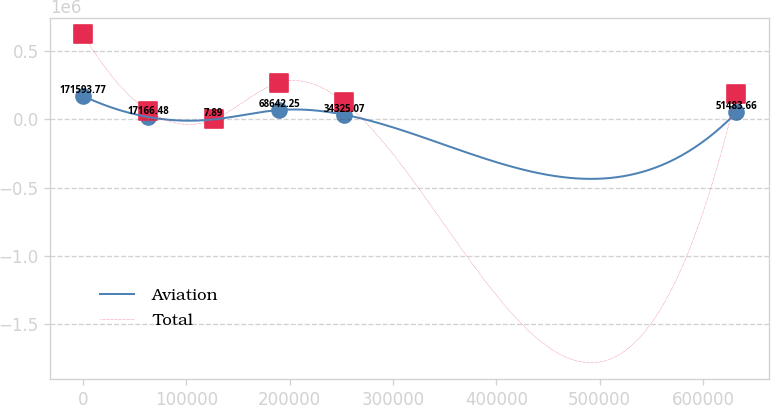<chart> <loc_0><loc_0><loc_500><loc_500><line_chart><ecel><fcel>Aviation<fcel>Total<nl><fcel>32.27<fcel>171594<fcel>623626<nl><fcel>63261.7<fcel>17166.5<fcel>62392.2<nl><fcel>126491<fcel>7.89<fcel>32.91<nl><fcel>189721<fcel>68642.2<fcel>270071<nl><fcel>252950<fcel>34325.1<fcel>124752<nl><fcel>632327<fcel>51483.7<fcel>187111<nl></chart> 